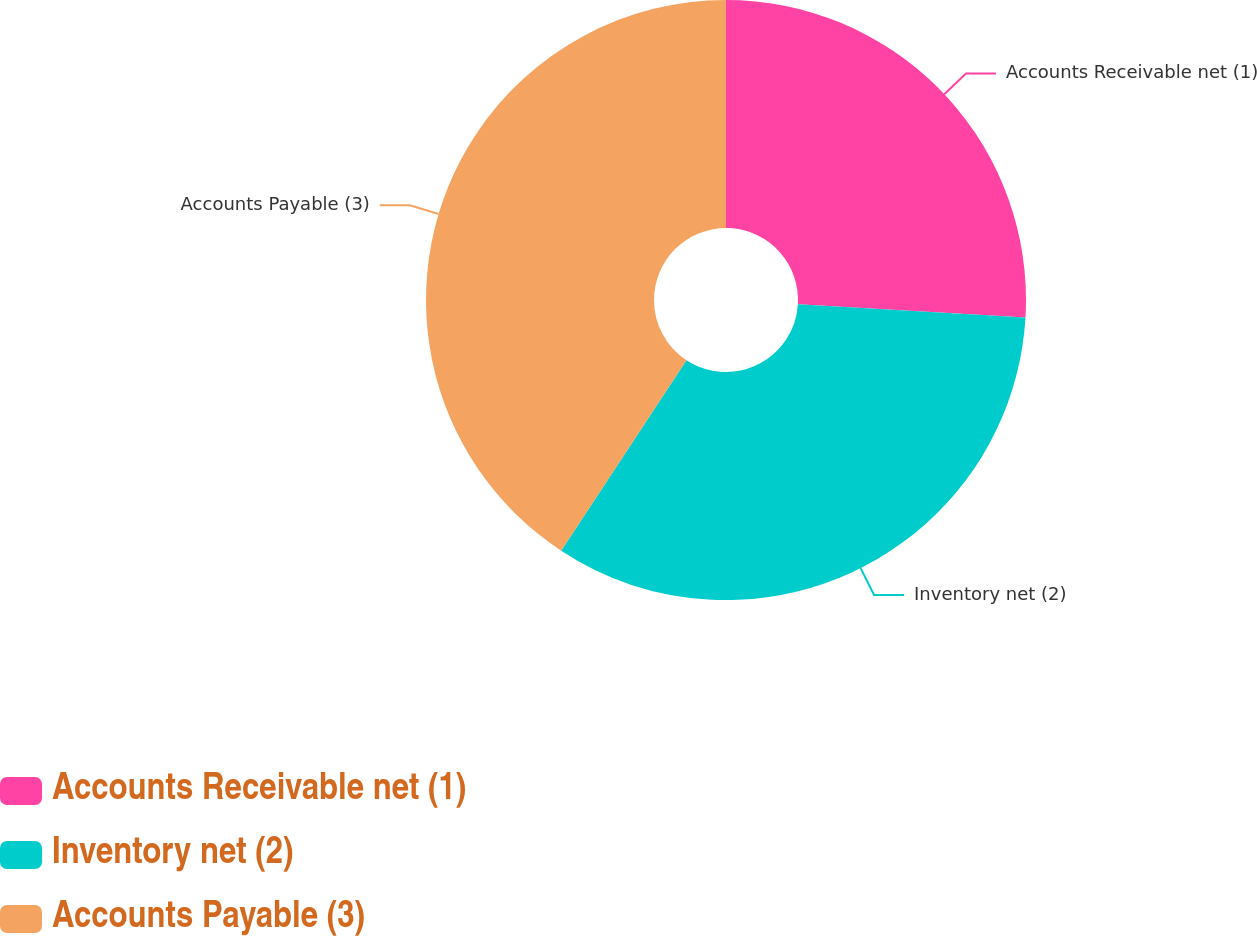Convert chart. <chart><loc_0><loc_0><loc_500><loc_500><pie_chart><fcel>Accounts Receivable net (1)<fcel>Inventory net (2)<fcel>Accounts Payable (3)<nl><fcel>25.93%<fcel>33.33%<fcel>40.74%<nl></chart> 